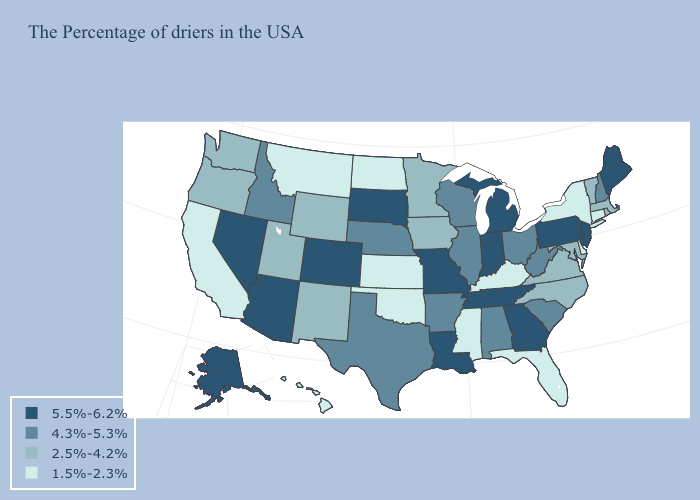What is the highest value in states that border West Virginia?
Give a very brief answer. 5.5%-6.2%. What is the highest value in the West ?
Write a very short answer. 5.5%-6.2%. Does Wyoming have a lower value than Connecticut?
Be succinct. No. What is the value of South Carolina?
Short answer required. 4.3%-5.3%. Does the first symbol in the legend represent the smallest category?
Short answer required. No. Does the first symbol in the legend represent the smallest category?
Answer briefly. No. What is the value of Nevada?
Quick response, please. 5.5%-6.2%. Name the states that have a value in the range 1.5%-2.3%?
Answer briefly. Connecticut, New York, Delaware, Florida, Kentucky, Mississippi, Kansas, Oklahoma, North Dakota, Montana, California, Hawaii. What is the highest value in the USA?
Concise answer only. 5.5%-6.2%. Which states have the lowest value in the West?
Short answer required. Montana, California, Hawaii. What is the value of North Dakota?
Write a very short answer. 1.5%-2.3%. How many symbols are there in the legend?
Short answer required. 4. What is the highest value in the USA?
Short answer required. 5.5%-6.2%. Name the states that have a value in the range 4.3%-5.3%?
Concise answer only. New Hampshire, South Carolina, West Virginia, Ohio, Alabama, Wisconsin, Illinois, Arkansas, Nebraska, Texas, Idaho. Name the states that have a value in the range 1.5%-2.3%?
Be succinct. Connecticut, New York, Delaware, Florida, Kentucky, Mississippi, Kansas, Oklahoma, North Dakota, Montana, California, Hawaii. 